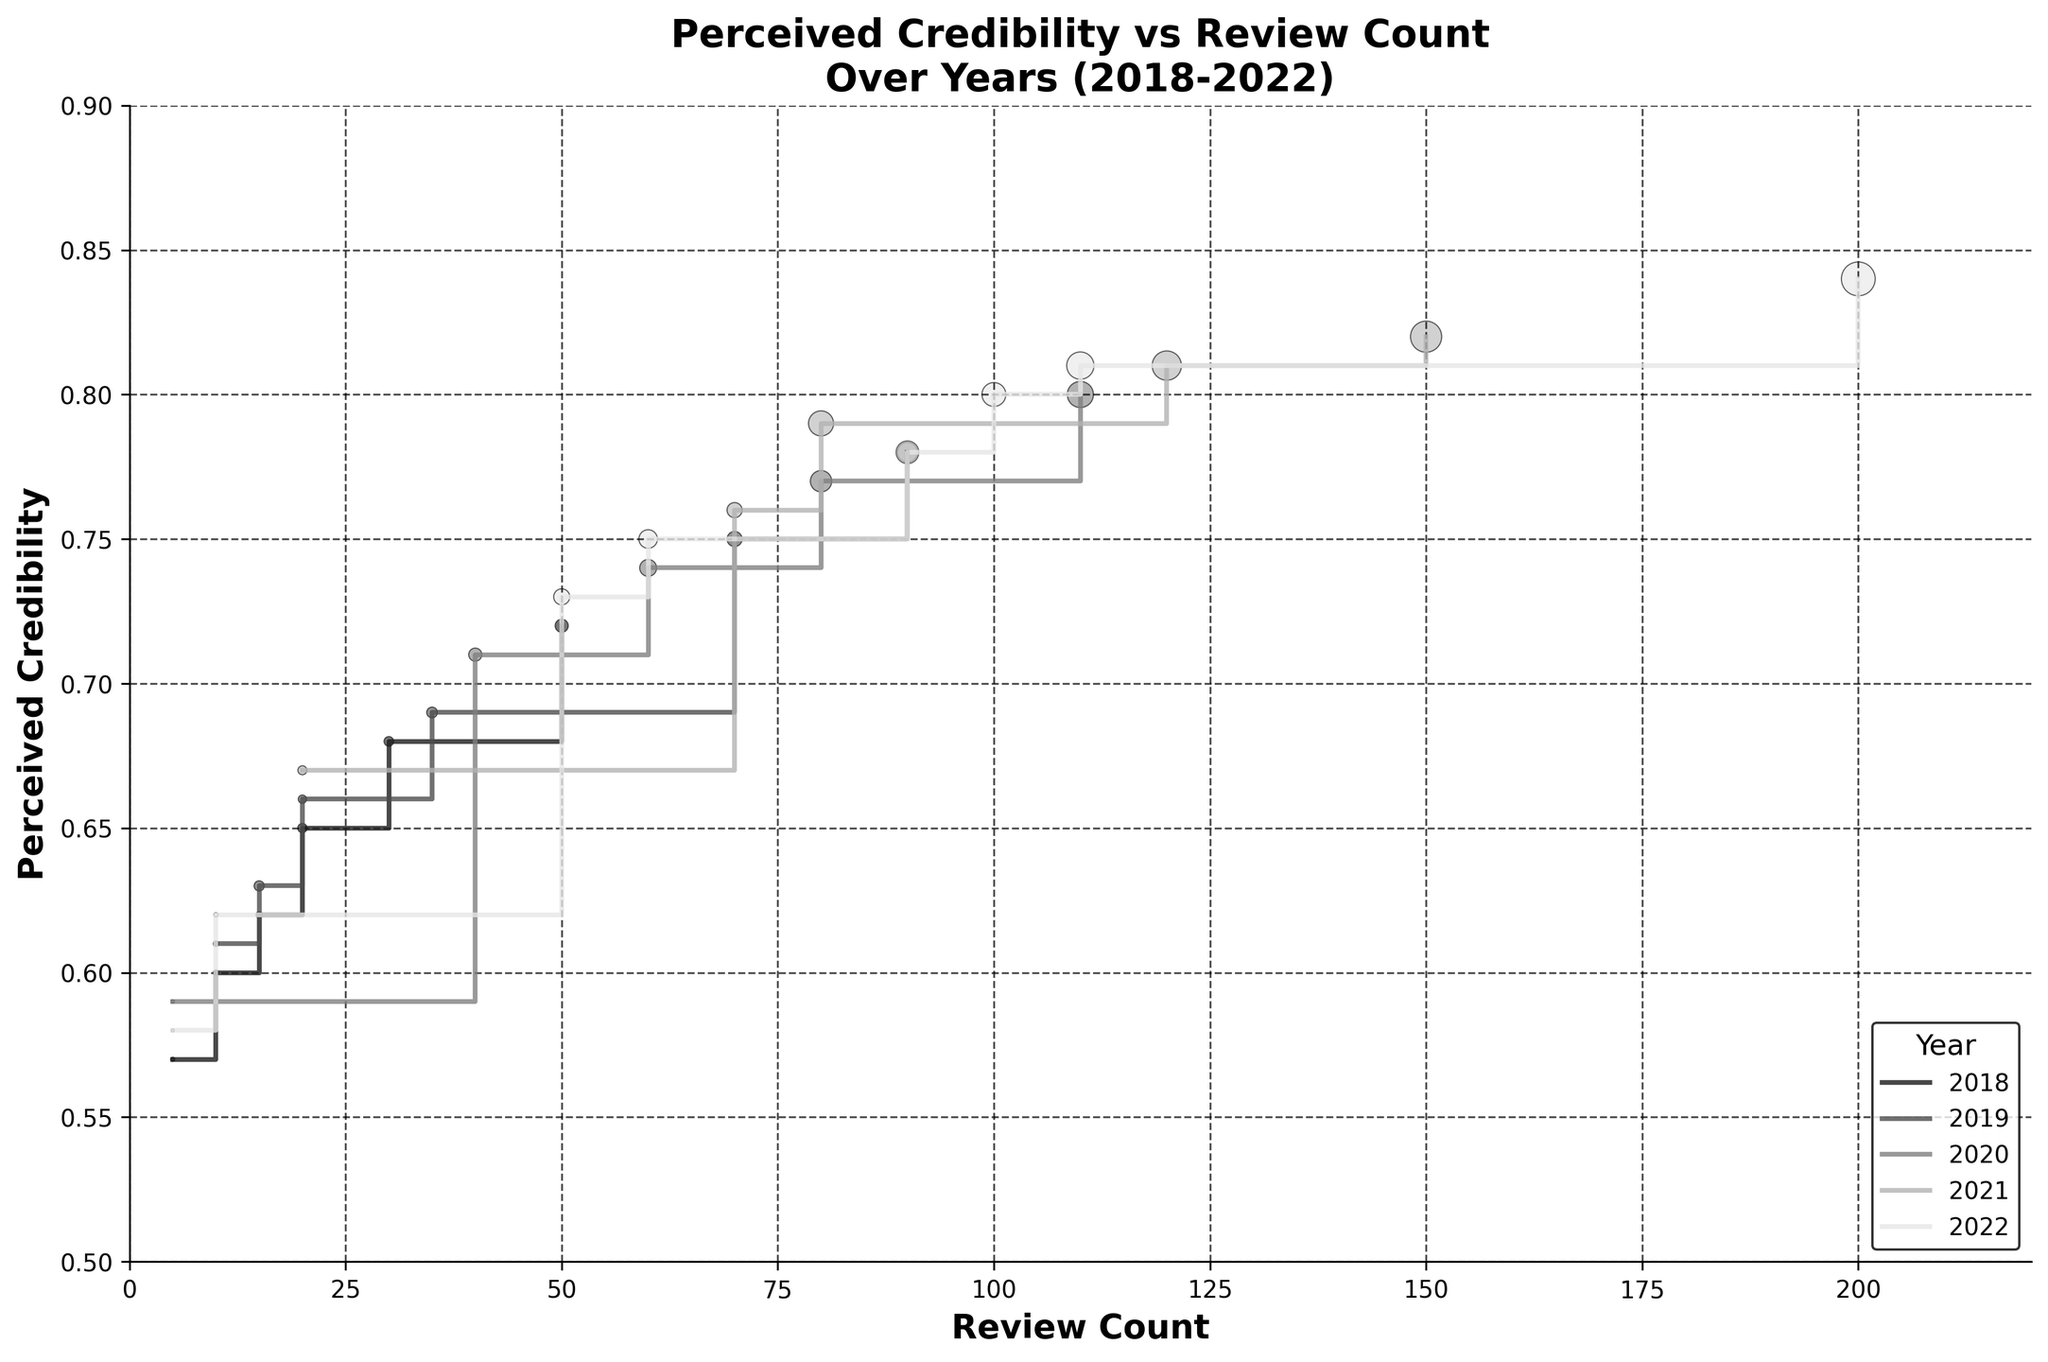What is the title of the figure? The title of the figure is typically located at the top and is clearly indicated in the figure.
Answer: Perceived Credibility vs Review Count Over Years (2018-2022) How many years are represented in the figure? The legend at the bottom right of the figure shows different years represented with distinct colors. Counting the different years gives the answer.
Answer: 5 What color represents the data for the year 2019? The legend in the figure associates each year with a specific color. The color for 2019 can be identified from this legend.
Answer: Dark Gray What is the highest perceived credibility in 2022? The stair plot allows us to see the peak points of perceived credibility for each year. The highest point for 2022 can be identified by following the steps upwards.
Answer: 0.84 Which year shows the steepest increase in perceived credibility? By comparing the slopes of the step functions for different years in the plot, the year with the steepest sections shows the most significant increases in perceived credibility.
Answer: 2021 What is the perceived credibility for a reviewer with 50 reviews and 300 followers in 2018? To find this, locate the data point where Review Count is 50 in the 2018 data and find the corresponding Perceived Credibility value.
Answer: 0.72 How does the perceived credibility for reviewers with 10 reviews change from 2018 to 2022? Locate the points for Review Count of 10 in each year and compare the perceived credibility values for those years.
Answer: 0.60 to 0.62 If follower count is shown by the size of the markers, which year likely has the reviewer with the most followers? The size of markers represents the follower count. The year with the largest marker size likely has the reviewer with the most followers.
Answer: 2022 What trend can you observe about the perceived credibility of top reviewers (with the highest review counts) over the years? By following the step functions for the highest review counts across different years, we can observe the changes or trends in perceived credibility.
Answer: Increasing In which year does a reviewer with around 110 reviews have the highest perceived credibility? Identify the year-by-year plot and find the year where the 110-review count point reaches the highest perceived credibility value.
Answer: 2022 